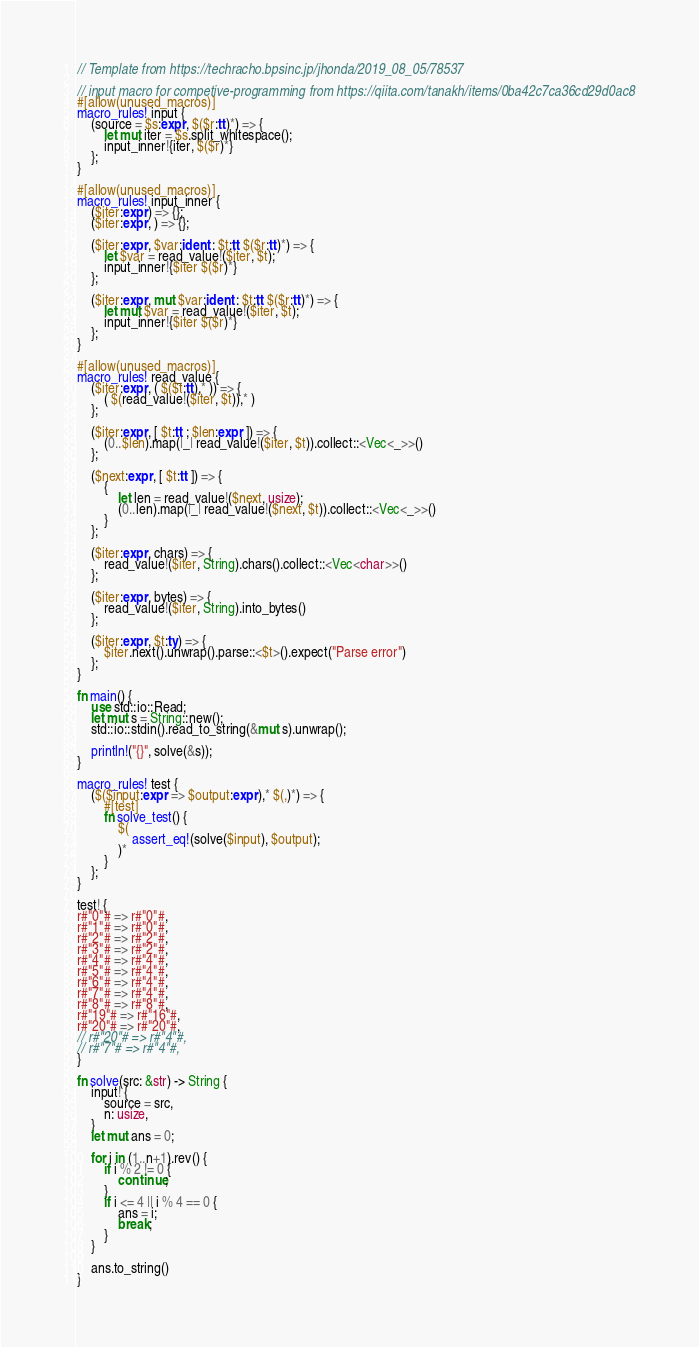Convert code to text. <code><loc_0><loc_0><loc_500><loc_500><_Rust_>// Template from https://techracho.bpsinc.jp/jhonda/2019_08_05/78537

// input macro for competive-programming from https://qiita.com/tanakh/items/0ba42c7ca36cd29d0ac8
#[allow(unused_macros)]
macro_rules! input {
    (source = $s:expr, $($r:tt)*) => {
        let mut iter = $s.split_whitespace();
        input_inner!{iter, $($r)*}
    };
}

#[allow(unused_macros)]
macro_rules! input_inner {
    ($iter:expr) => {};
    ($iter:expr, ) => {};

    ($iter:expr, $var:ident : $t:tt $($r:tt)*) => {
        let $var = read_value!($iter, $t);
        input_inner!{$iter $($r)*}
    };

    ($iter:expr, mut $var:ident : $t:tt $($r:tt)*) => {
        let mut $var = read_value!($iter, $t);
        input_inner!{$iter $($r)*}
    };
}

#[allow(unused_macros)]
macro_rules! read_value {
    ($iter:expr, ( $($t:tt),* )) => {
        ( $(read_value!($iter, $t)),* )
    };

    ($iter:expr, [ $t:tt ; $len:expr ]) => {
        (0..$len).map(|_| read_value!($iter, $t)).collect::<Vec<_>>()
    };

    ($next:expr, [ $t:tt ]) => {
        {
            let len = read_value!($next, usize);
            (0..len).map(|_| read_value!($next, $t)).collect::<Vec<_>>()
        }
    };

    ($iter:expr, chars) => {
        read_value!($iter, String).chars().collect::<Vec<char>>()
    };

    ($iter:expr, bytes) => {
        read_value!($iter, String).into_bytes()
    };

    ($iter:expr, $t:ty) => {
        $iter.next().unwrap().parse::<$t>().expect("Parse error")
    };
}

fn main() {
    use std::io::Read;
    let mut s = String::new();
    std::io::stdin().read_to_string(&mut s).unwrap();

    println!("{}", solve(&s));
}

macro_rules! test {
    ($($input:expr => $output:expr),* $(,)*) => {
        #[test]
        fn solve_test() {
            $(
                assert_eq!(solve($input), $output);
            )*
        }
    };
}

test! {
r#"0"# => r#"0"#,
r#"1"# => r#"0"#,
r#"2"# => r#"2"#,
r#"3"# => r#"2"#,
r#"4"# => r#"4"#,
r#"5"# => r#"4"#,
r#"6"# => r#"4"#,
r#"7"# => r#"4"#,
r#"8"# => r#"8"#,
r#"19"# => r#"16"#,
r#"20"# => r#"20"#,
// r#"20"# => r#"4"#,
// r#"7"# => r#"4"#,
}

fn solve(src: &str) -> String {
    input! {
        source = src,
        n: usize,
    }
    let mut ans = 0;

    for i in (1..n+1).rev() {
        if i % 2 != 0 {
            continue;
        }
        if i <= 4 || i % 4 == 0 {
            ans = i;
            break;
        }
    }

    ans.to_string()
}</code> 